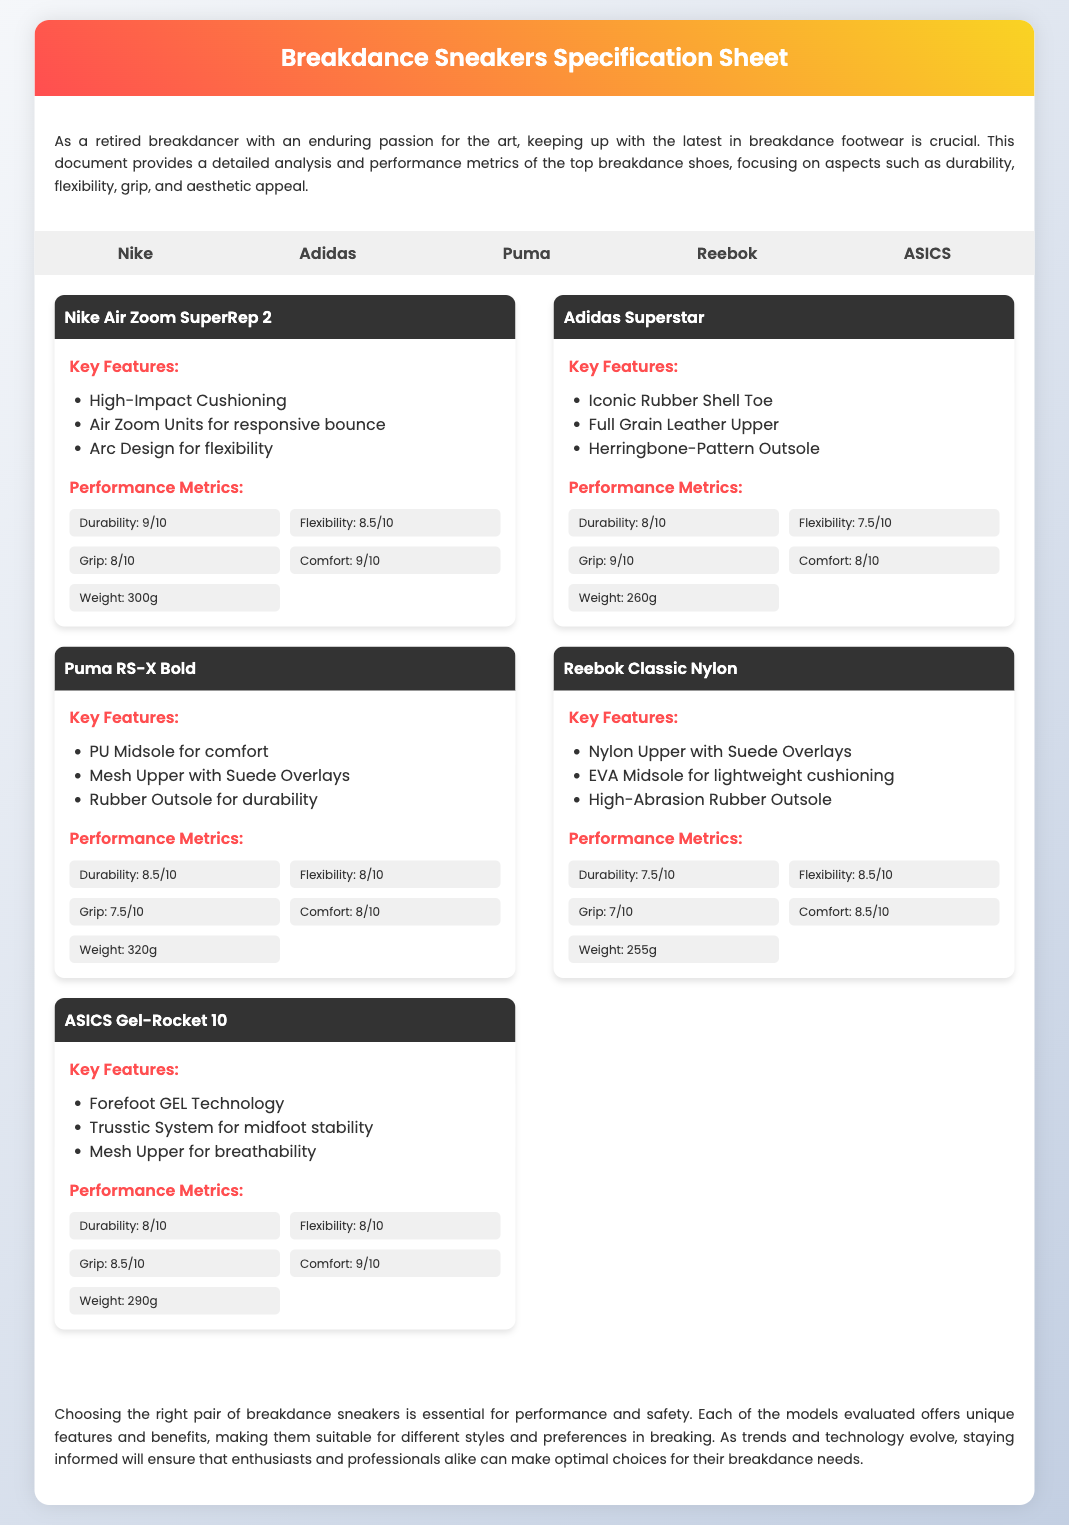What is the maximum durability rating among the sneakers? The maximum durability rating is found in the Nike Air Zoom SuperRep 2, which has a rating of 9/10.
Answer: 9/10 Which brand features the iconic rubber shell toe? The Adidas Superstar features the iconic rubber shell toe as one of its key features.
Answer: Adidas What is the weight of the Puma RS-X Bold? The weight of the Puma RS-X Bold is specified as 320 grams.
Answer: 320g Which sneaker has the highest grip rating? The Adidas Superstar has the highest grip rating of 9/10 among the listed sneakers.
Answer: 9/10 What are the key features of the ASICS Gel-Rocket 10? The key features include Forefoot GEL Technology, Trusstic System for midfoot stability, and Mesh Upper for breathability.
Answer: Forefoot GEL Technology, Trusstic System, Mesh Upper What is the overall comfort rating of the Reebok Classic Nylon? The comfort rating of the Reebok Classic Nylon is 8.5/10.
Answer: 8.5/10 Which sneaker offers the best flexibility rating? The Reebok Classic Nylon offers the best flexibility rating at 8.5/10.
Answer: 8.5/10 What is the total number of different brands mentioned in the document? The document mentions five different brands of breakdance sneakers.
Answer: 5 